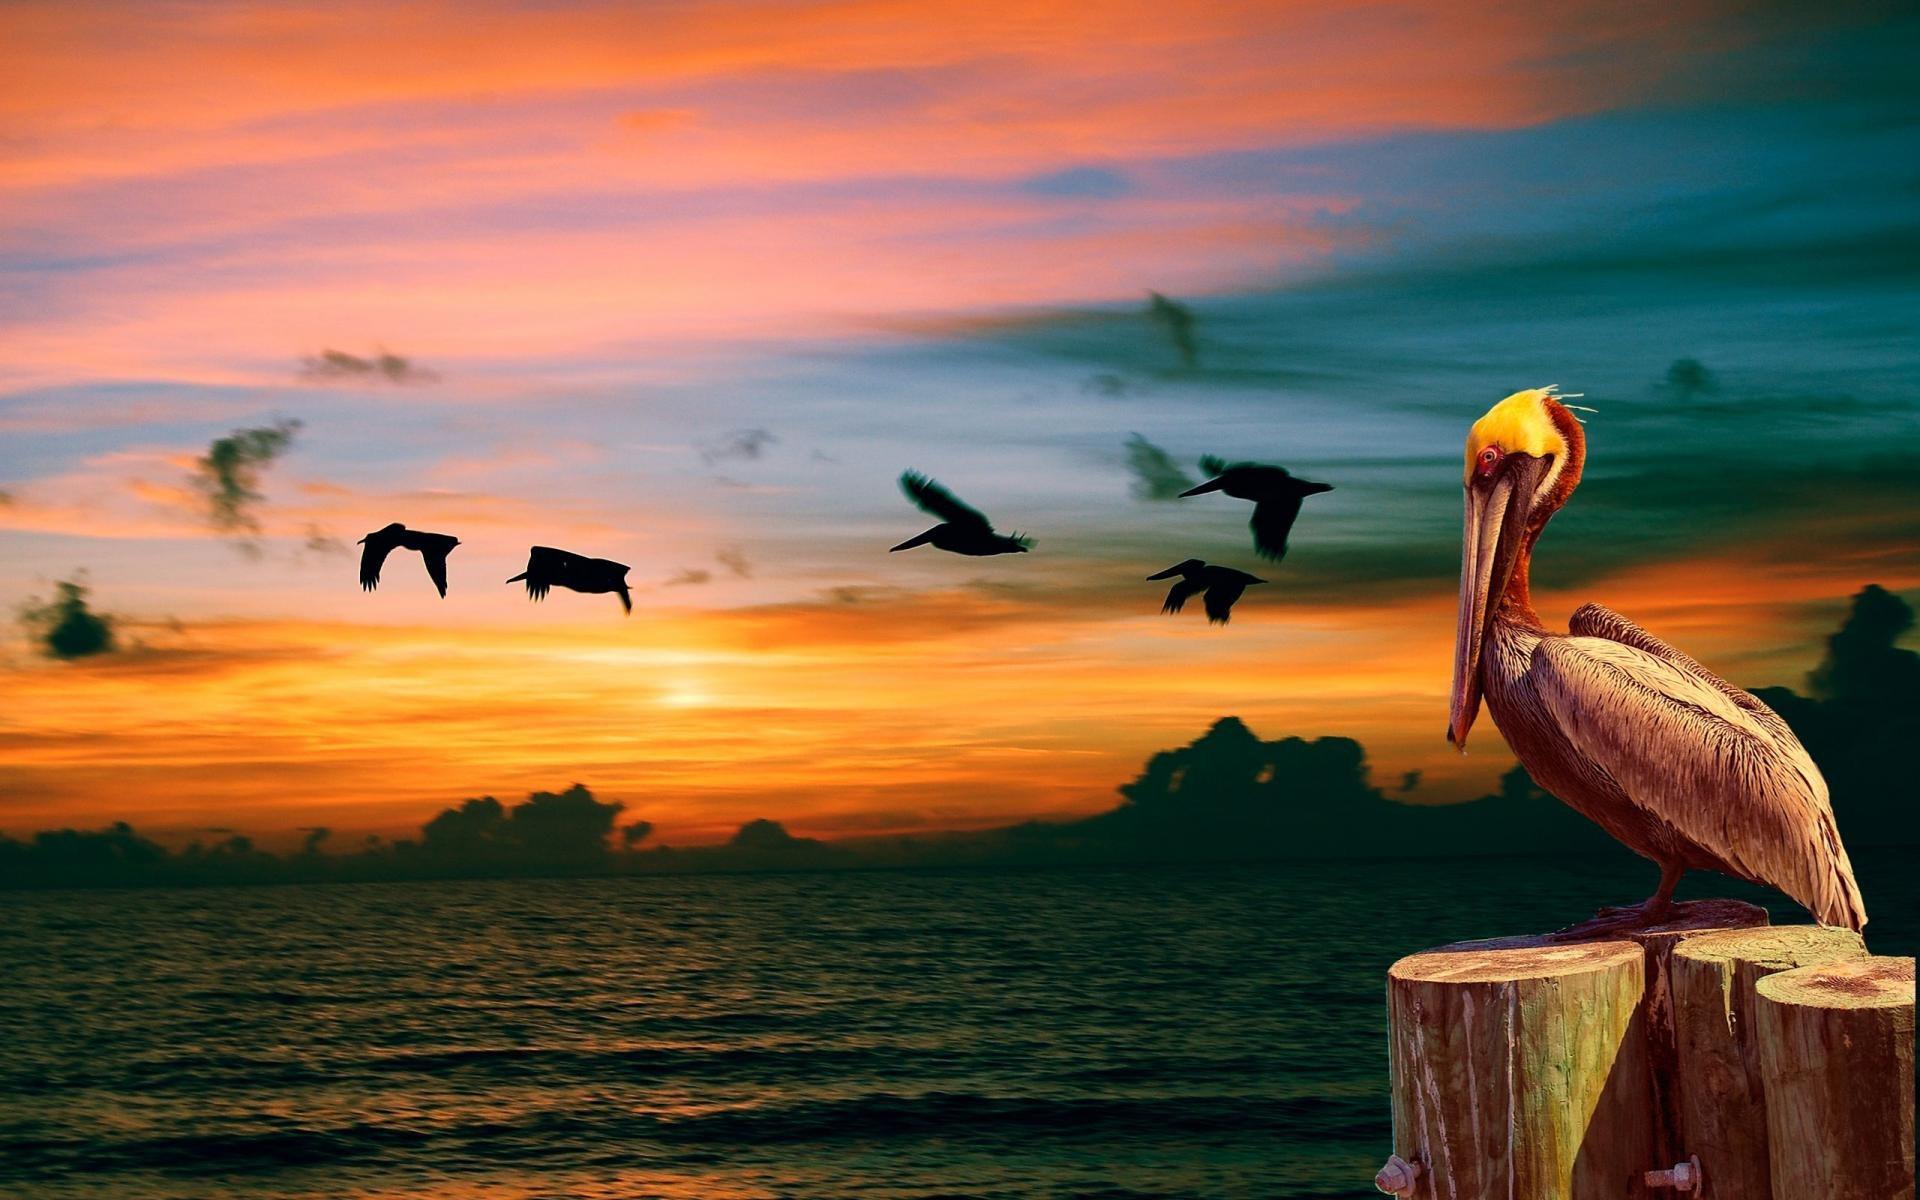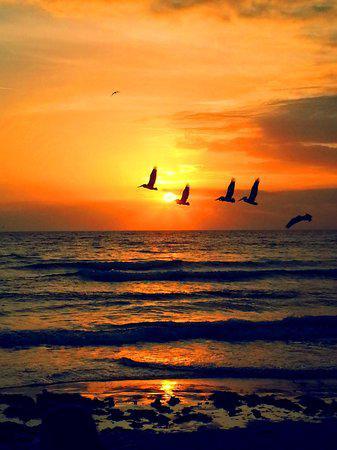The first image is the image on the left, the second image is the image on the right. For the images shown, is this caption "A pelican perches on a pole in the image on the left." true? Answer yes or no. Yes. The first image is the image on the left, the second image is the image on the right. For the images shown, is this caption "An image shows a pelican perched on a tall post next to a shorter post, in front of a sky with no birds flying across it." true? Answer yes or no. No. 